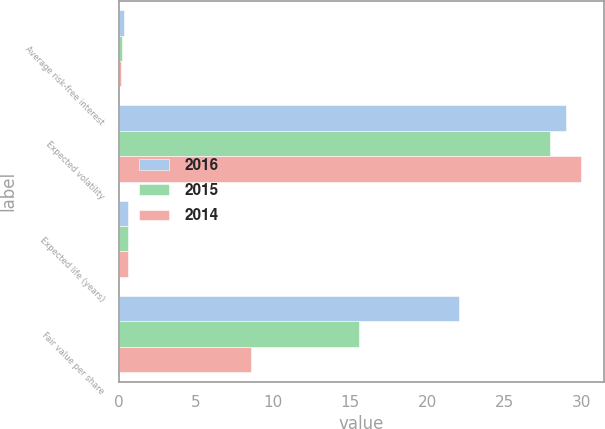Convert chart. <chart><loc_0><loc_0><loc_500><loc_500><stacked_bar_chart><ecel><fcel>Average risk-free interest<fcel>Expected volatility<fcel>Expected life (years)<fcel>Fair value per share<nl><fcel>2016<fcel>0.3<fcel>29<fcel>0.6<fcel>22.09<nl><fcel>2015<fcel>0.2<fcel>28<fcel>0.6<fcel>15.59<nl><fcel>2014<fcel>0.1<fcel>30<fcel>0.6<fcel>8.59<nl></chart> 